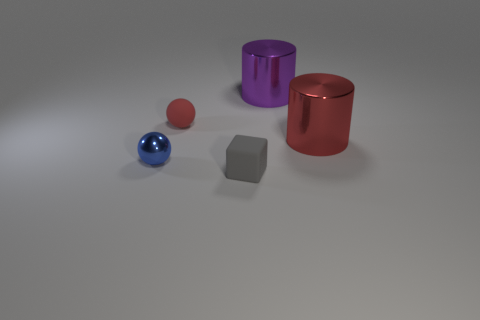Add 2 small gray things. How many objects exist? 7 Subtract all cubes. How many objects are left? 4 Subtract 0 green spheres. How many objects are left? 5 Subtract all brown rubber spheres. Subtract all large red metal things. How many objects are left? 4 Add 2 large metallic cylinders. How many large metallic cylinders are left? 4 Add 3 tiny yellow metallic spheres. How many tiny yellow metallic spheres exist? 3 